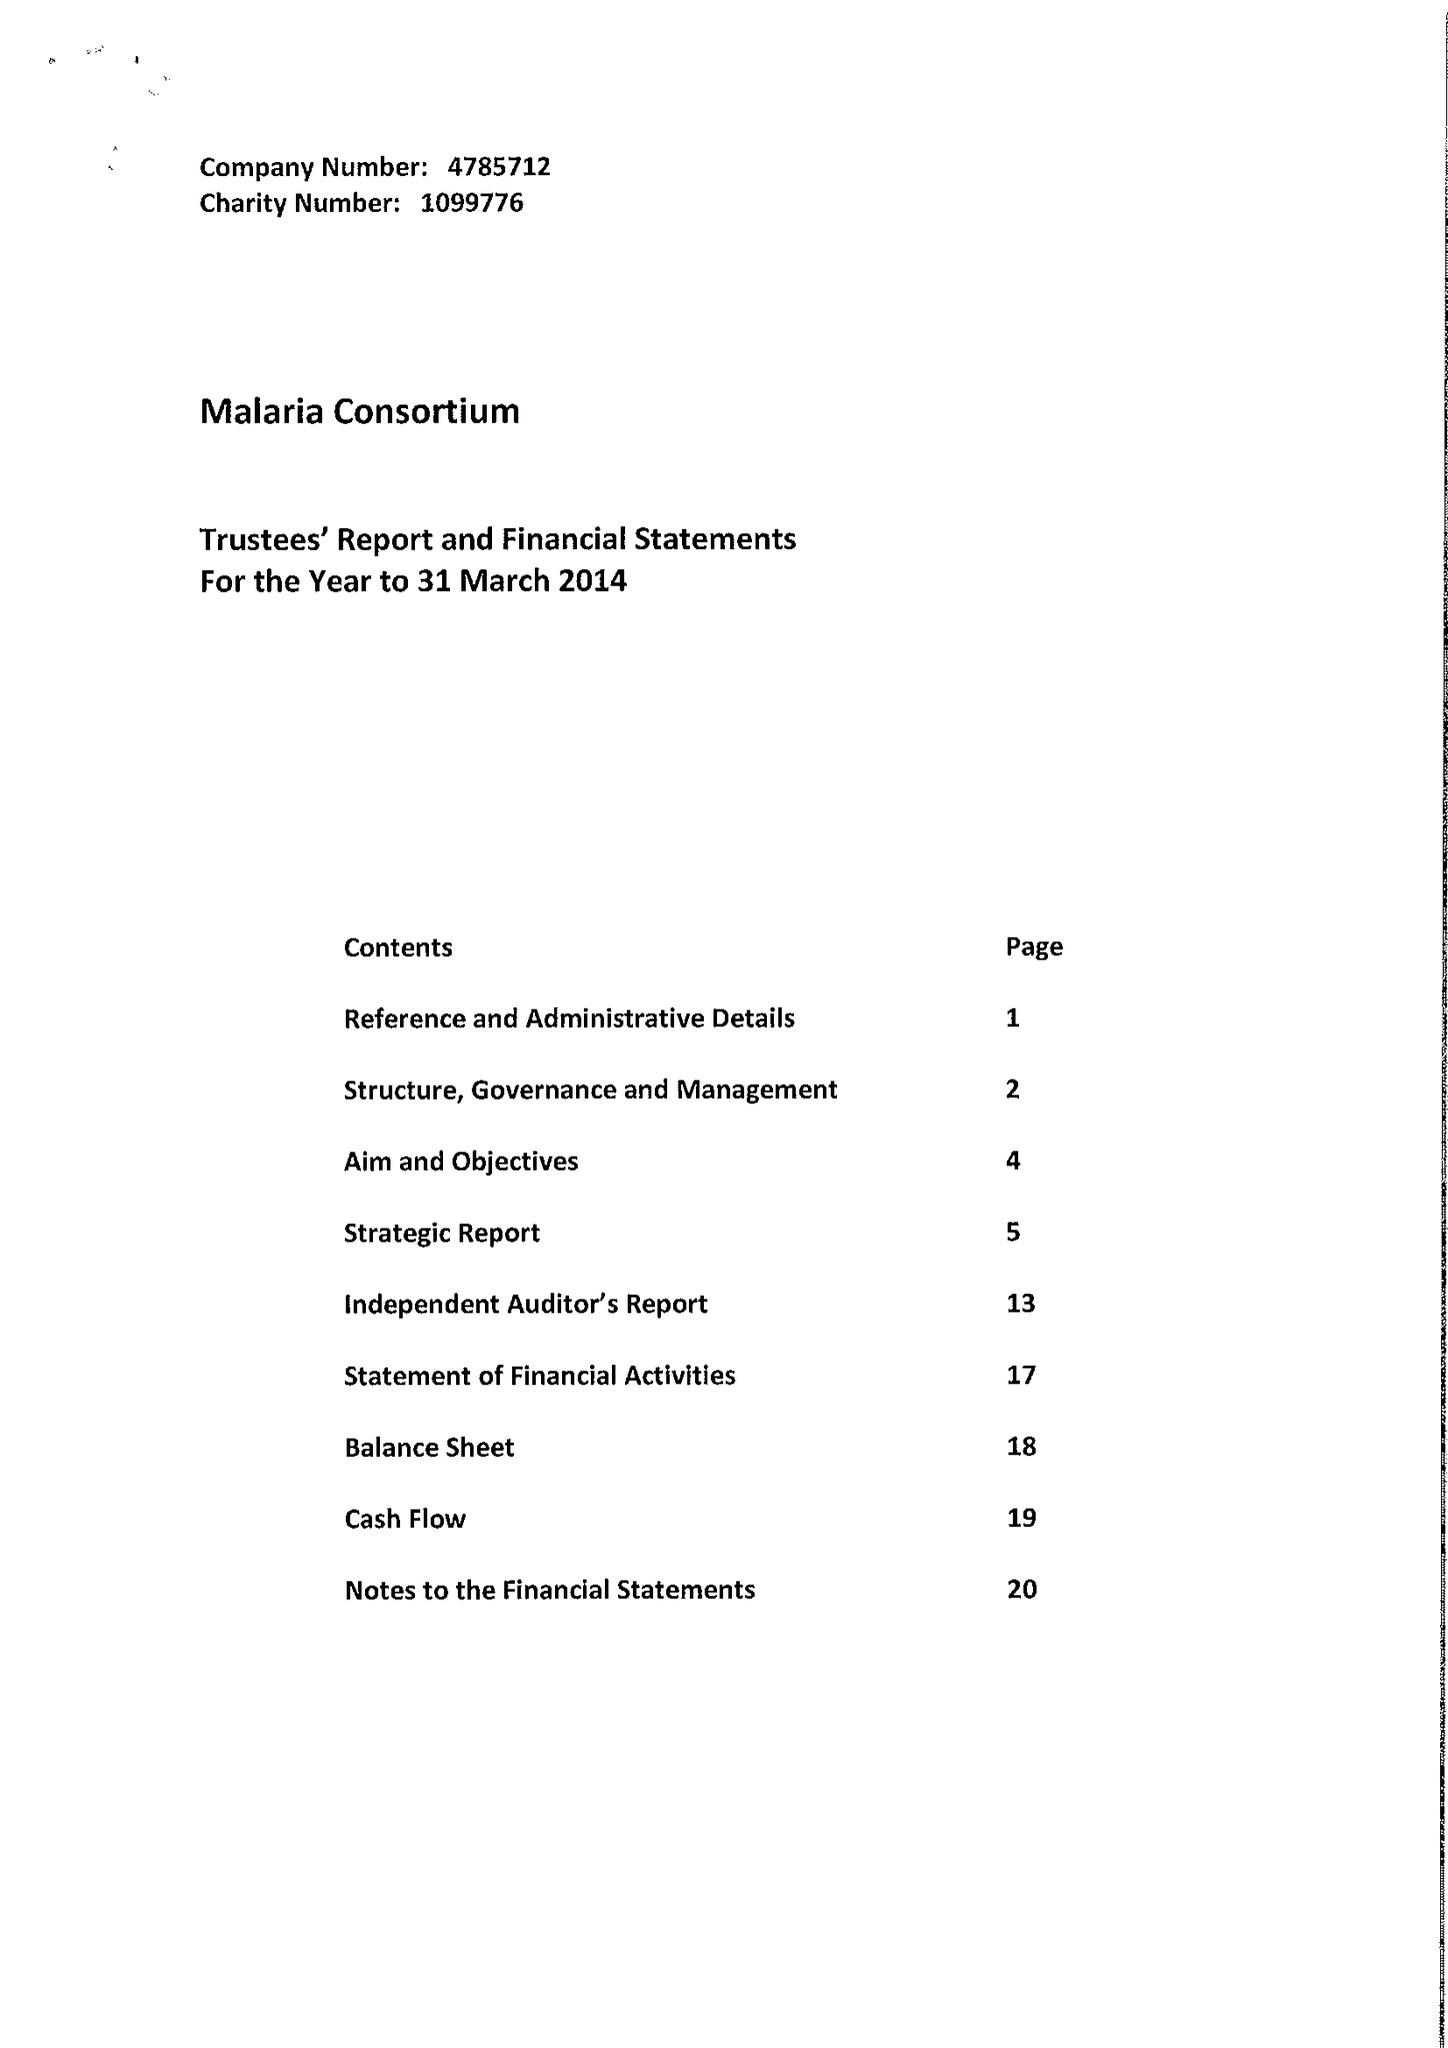What is the value for the address__postcode?
Answer the question using a single word or phrase. E2 9DA 